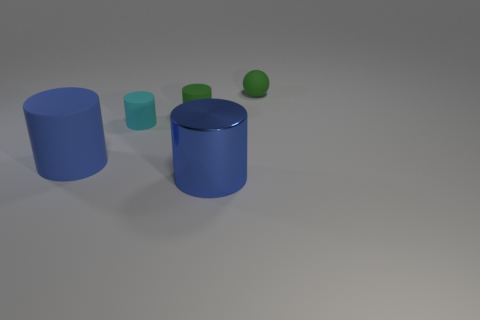What size is the metallic object that is the same color as the big rubber cylinder?
Ensure brevity in your answer.  Large. What is the material of the tiny object that is on the left side of the green matte cylinder that is behind the cyan matte cylinder?
Your answer should be very brief. Rubber. Are there fewer tiny rubber spheres that are to the left of the large blue metallic cylinder than blue metal cylinders in front of the green matte sphere?
Offer a terse response. Yes. How many blue things are either large rubber cylinders or metal cylinders?
Give a very brief answer. 2. Are there the same number of rubber things that are behind the big rubber cylinder and cyan rubber cylinders?
Your answer should be very brief. No. How many objects are large blue shiny things or matte cylinders to the right of the large matte cylinder?
Your answer should be compact. 3. Is the large matte thing the same color as the large metal thing?
Your answer should be compact. Yes. Are there any tiny cylinders that have the same material as the tiny sphere?
Make the answer very short. Yes. What color is the other small thing that is the same shape as the cyan thing?
Your response must be concise. Green. Do the cyan object and the green object that is in front of the tiny sphere have the same material?
Offer a very short reply. Yes. 